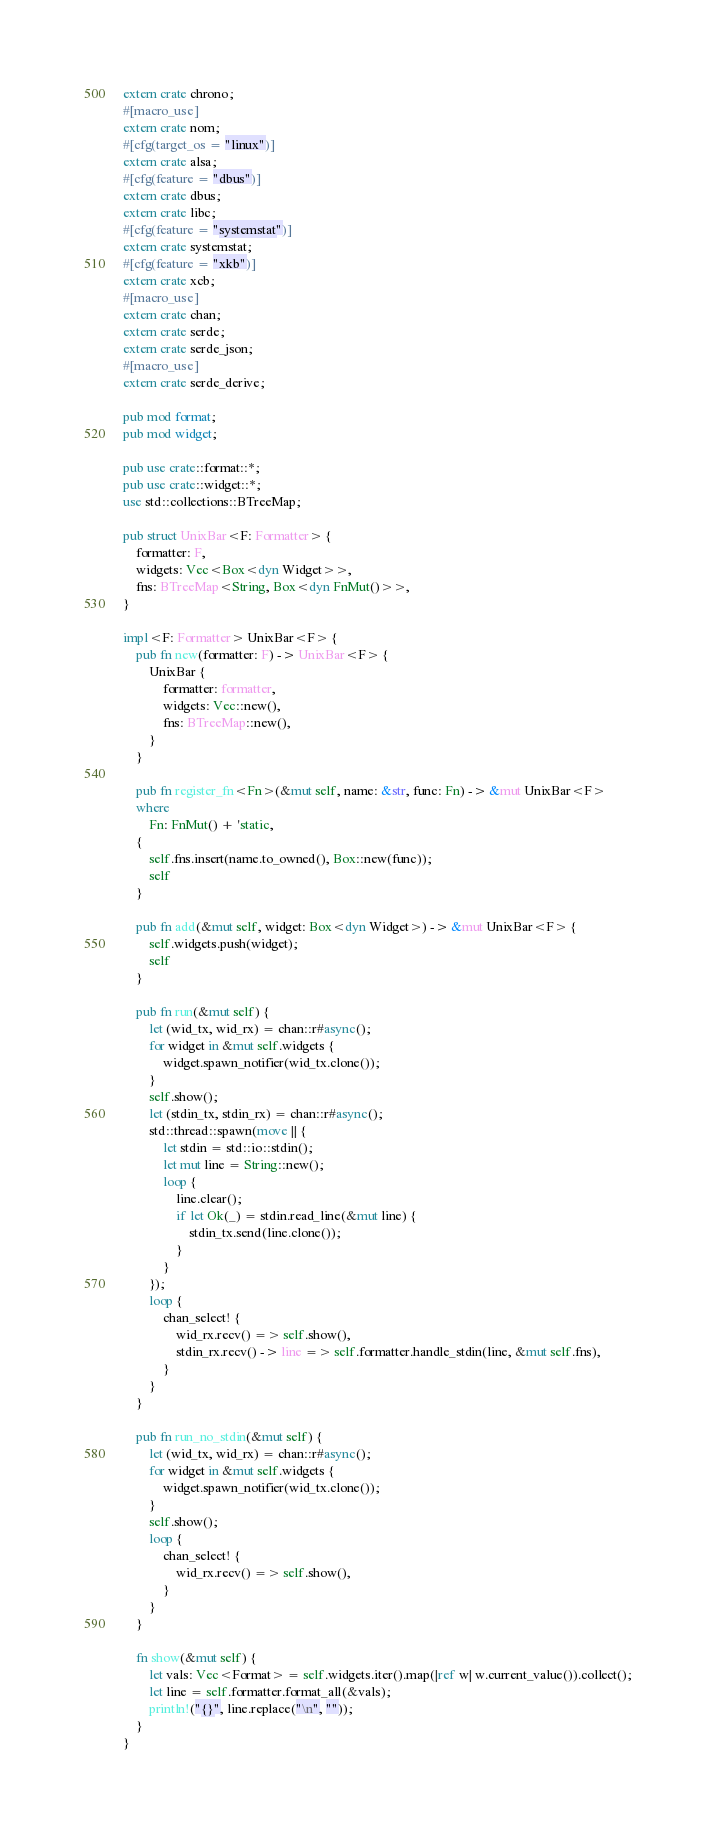<code> <loc_0><loc_0><loc_500><loc_500><_Rust_>extern crate chrono;
#[macro_use]
extern crate nom;
#[cfg(target_os = "linux")]
extern crate alsa;
#[cfg(feature = "dbus")]
extern crate dbus;
extern crate libc;
#[cfg(feature = "systemstat")]
extern crate systemstat;
#[cfg(feature = "xkb")]
extern crate xcb;
#[macro_use]
extern crate chan;
extern crate serde;
extern crate serde_json;
#[macro_use]
extern crate serde_derive;

pub mod format;
pub mod widget;

pub use crate::format::*;
pub use crate::widget::*;
use std::collections::BTreeMap;

pub struct UnixBar<F: Formatter> {
    formatter: F,
    widgets: Vec<Box<dyn Widget>>,
    fns: BTreeMap<String, Box<dyn FnMut()>>,
}

impl<F: Formatter> UnixBar<F> {
    pub fn new(formatter: F) -> UnixBar<F> {
        UnixBar {
            formatter: formatter,
            widgets: Vec::new(),
            fns: BTreeMap::new(),
        }
    }

    pub fn register_fn<Fn>(&mut self, name: &str, func: Fn) -> &mut UnixBar<F>
    where
        Fn: FnMut() + 'static,
    {
        self.fns.insert(name.to_owned(), Box::new(func));
        self
    }

    pub fn add(&mut self, widget: Box<dyn Widget>) -> &mut UnixBar<F> {
        self.widgets.push(widget);
        self
    }

    pub fn run(&mut self) {
        let (wid_tx, wid_rx) = chan::r#async();
        for widget in &mut self.widgets {
            widget.spawn_notifier(wid_tx.clone());
        }
        self.show();
        let (stdin_tx, stdin_rx) = chan::r#async();
        std::thread::spawn(move || {
            let stdin = std::io::stdin();
            let mut line = String::new();
            loop {
                line.clear();
                if let Ok(_) = stdin.read_line(&mut line) {
                    stdin_tx.send(line.clone());
                }
            }
        });
        loop {
            chan_select! {
                wid_rx.recv() => self.show(),
                stdin_rx.recv() -> line => self.formatter.handle_stdin(line, &mut self.fns),
            }
        }
    }

    pub fn run_no_stdin(&mut self) {
        let (wid_tx, wid_rx) = chan::r#async();
        for widget in &mut self.widgets {
            widget.spawn_notifier(wid_tx.clone());
        }
        self.show();
        loop {
            chan_select! {
                wid_rx.recv() => self.show(),
            }
        }
    }

    fn show(&mut self) {
        let vals: Vec<Format> = self.widgets.iter().map(|ref w| w.current_value()).collect();
        let line = self.formatter.format_all(&vals);
        println!("{}", line.replace("\n", ""));
    }
}
</code> 